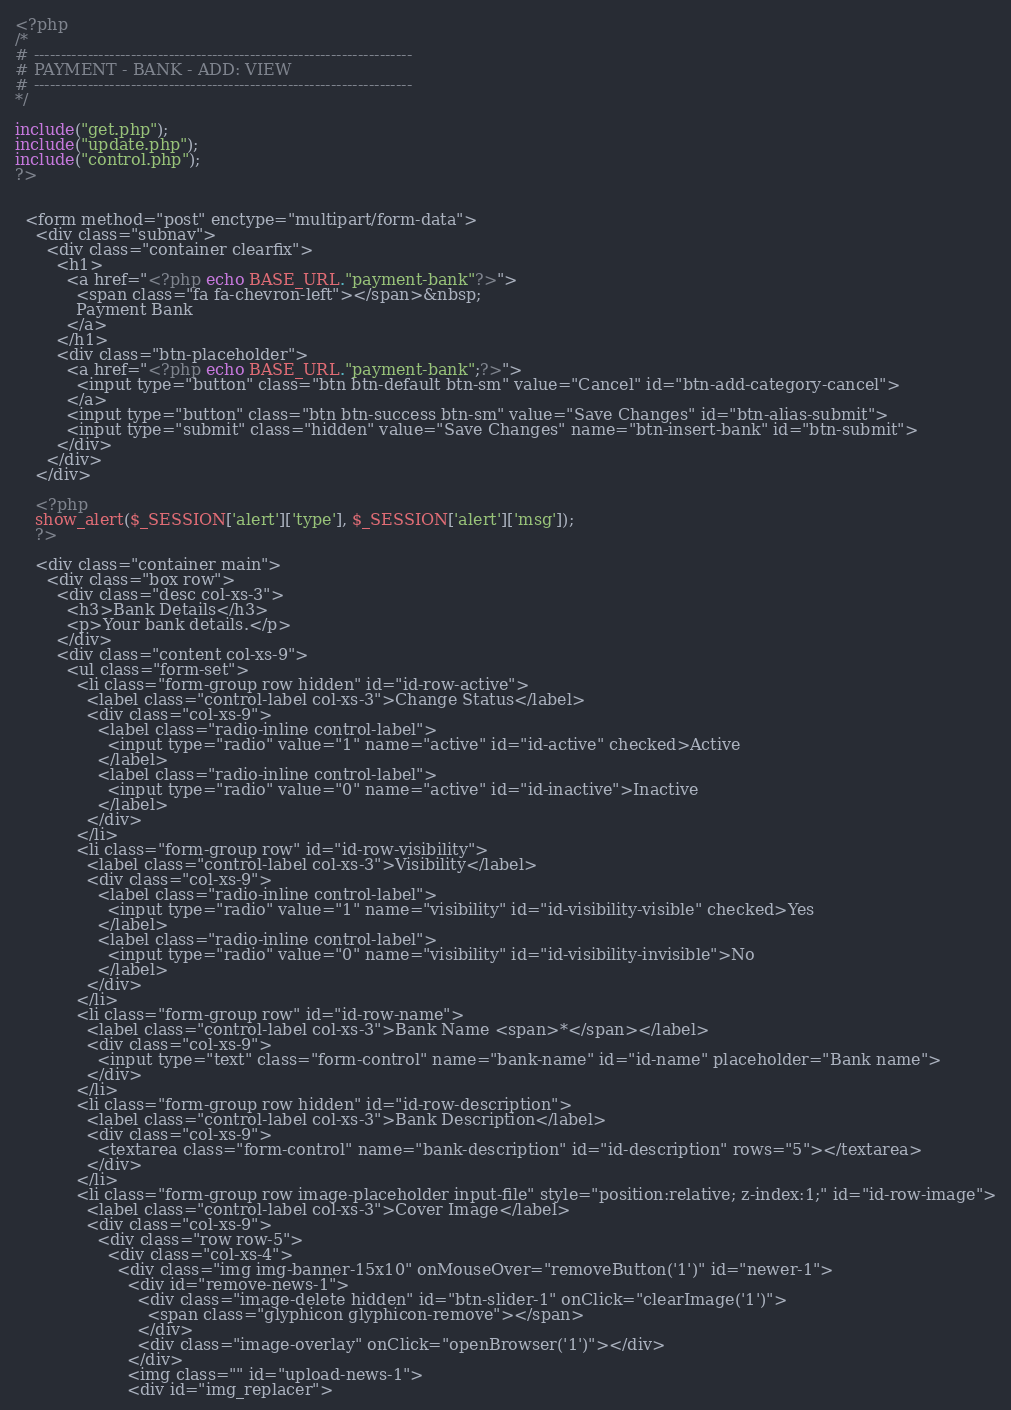<code> <loc_0><loc_0><loc_500><loc_500><_PHP_><?php
/*
# ----------------------------------------------------------------------
# PAYMENT - BANK - ADD: VIEW
# ----------------------------------------------------------------------
*/

include("get.php");
include("update.php");
include("control.php");
?> 
        

  <form method="post" enctype="multipart/form-data">
    <div class="subnav">
      <div class="container clearfix">
        <h1>
          <a href="<?php echo BASE_URL."payment-bank"?>">
            <span class="fa fa-chevron-left"></span>&nbsp;
            Payment Bank
          </a> 
        </h1>
        <div class="btn-placeholder">
          <a href="<?php echo BASE_URL."payment-bank";?>">
            <input type="button" class="btn btn-default btn-sm" value="Cancel" id="btn-add-category-cancel">
          </a>
          <input type="button" class="btn btn-success btn-sm" value="Save Changes" id="btn-alias-submit">
          <input type="submit" class="hidden" value="Save Changes" name="btn-insert-bank" id="btn-submit">
        </div>
      </div>
    </div>
    
	<?php
    show_alert($_SESSION['alert']['type'], $_SESSION['alert']['msg']);
	?> 

    <div class="container main">
      <div class="box row">
        <div class="desc col-xs-3">
          <h3>Bank Details</h3>
          <p>Your bank details.</p>
        </div>
        <div class="content col-xs-9">
          <ul class="form-set">
            <li class="form-group row hidden" id="id-row-active">
              <label class="control-label col-xs-3">Change Status</label>
              <div class="col-xs-9">
                <label class="radio-inline control-label">
                  <input type="radio" value="1" name="active" id="id-active" checked>Active
                </label>
                <label class="radio-inline control-label">
                  <input type="radio" value="0" name="active" id="id-inactive">Inactive
                </label>
              </div>
            </li>
            <li class="form-group row" id="id-row-visibility">
              <label class="control-label col-xs-3">Visibility</label>
              <div class="col-xs-9">
                <label class="radio-inline control-label">
                  <input type="radio" value="1" name="visibility" id="id-visibility-visible" checked>Yes
                </label>
                <label class="radio-inline control-label">
                  <input type="radio" value="0" name="visibility" id="id-visibility-invisible">No
                </label>
              </div>
            </li>
            <li class="form-group row" id="id-row-name">
              <label class="control-label col-xs-3">Bank Name <span>*</span></label>
              <div class="col-xs-9">
                <input type="text" class="form-control" name="bank-name" id="id-name" placeholder="Bank name">
              </div>
            </li>
            <li class="form-group row hidden" id="id-row-description">
              <label class="control-label col-xs-3">Bank Description</label>
              <div class="col-xs-9">
                <textarea class="form-control" name="bank-description" id="id-description" rows="5"></textarea>
              </div>
            </li>
            <li class="form-group row image-placeholder input-file" style="position:relative; z-index:1;" id="id-row-image">
              <label class="control-label col-xs-3">Cover Image</label>
              <div class="col-xs-9">
                <div class="row row-5">
                  <div class="col-xs-4">
                    <div class="img img-banner-15x10" onMouseOver="removeButton('1')" id="newer-1">
                      <div id="remove-news-1">
                        <div class="image-delete hidden" id="btn-slider-1" onClick="clearImage('1')">
                          <span class="glyphicon glyphicon-remove"></span>
                        </div>
                        <div class="image-overlay" onClick="openBrowser('1')"></div>
                      </div>
                      <img class="" id="upload-news-1">
                      <div id="img_replacer"></code> 